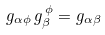Convert formula to latex. <formula><loc_0><loc_0><loc_500><loc_500>g _ { \alpha \phi } \, g _ { \beta } ^ { \, \phi } = g _ { \alpha \beta }</formula> 